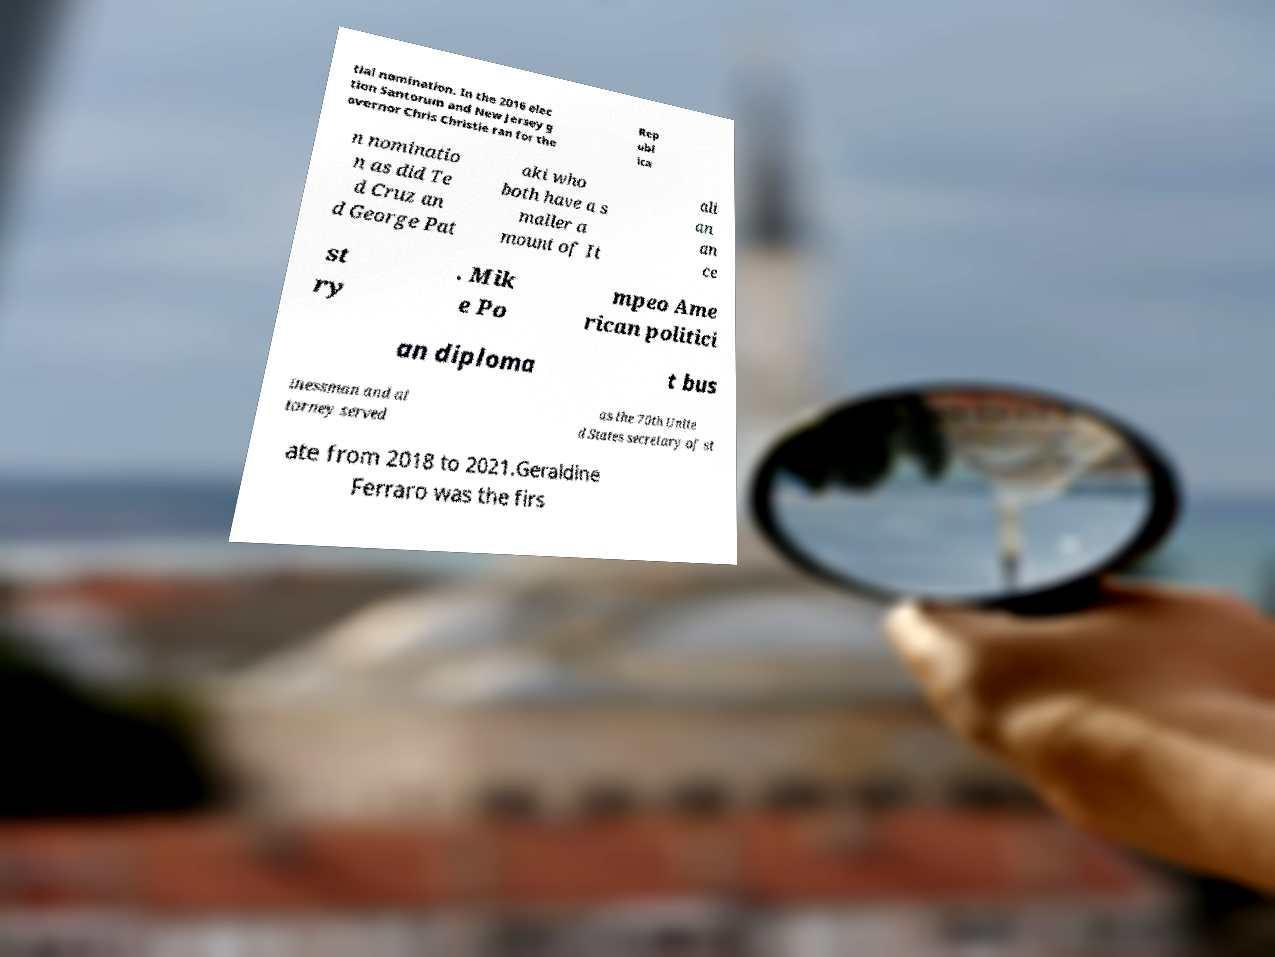Could you assist in decoding the text presented in this image and type it out clearly? tial nomination. In the 2016 elec tion Santorum and New Jersey g overnor Chris Christie ran for the Rep ubl ica n nominatio n as did Te d Cruz an d George Pat aki who both have a s maller a mount of It ali an an ce st ry . Mik e Po mpeo Ame rican politici an diploma t bus inessman and at torney served as the 70th Unite d States secretary of st ate from 2018 to 2021.Geraldine Ferraro was the firs 